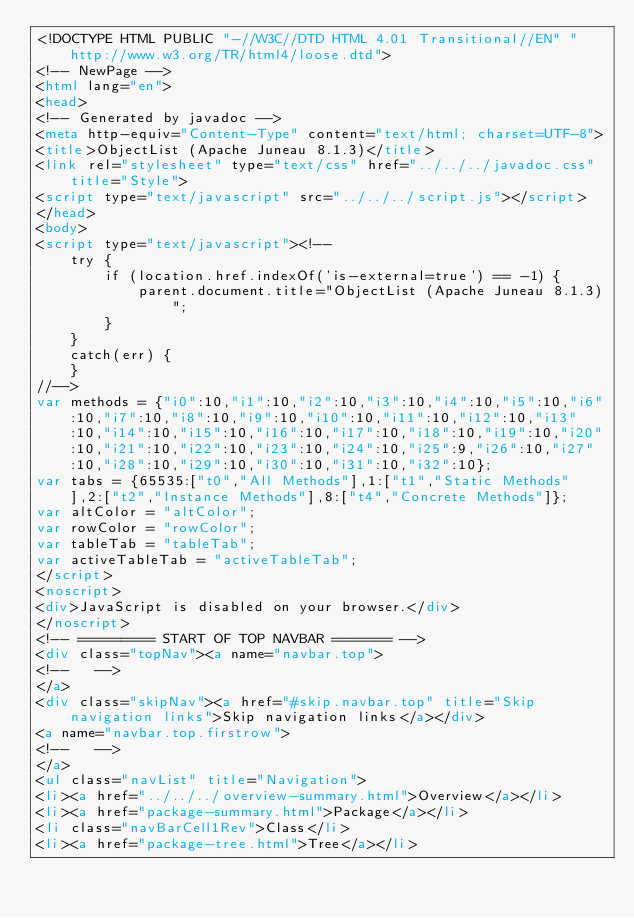Convert code to text. <code><loc_0><loc_0><loc_500><loc_500><_HTML_><!DOCTYPE HTML PUBLIC "-//W3C//DTD HTML 4.01 Transitional//EN" "http://www.w3.org/TR/html4/loose.dtd">
<!-- NewPage -->
<html lang="en">
<head>
<!-- Generated by javadoc -->
<meta http-equiv="Content-Type" content="text/html; charset=UTF-8">
<title>ObjectList (Apache Juneau 8.1.3)</title>
<link rel="stylesheet" type="text/css" href="../../../javadoc.css" title="Style">
<script type="text/javascript" src="../../../script.js"></script>
</head>
<body>
<script type="text/javascript"><!--
    try {
        if (location.href.indexOf('is-external=true') == -1) {
            parent.document.title="ObjectList (Apache Juneau 8.1.3)";
        }
    }
    catch(err) {
    }
//-->
var methods = {"i0":10,"i1":10,"i2":10,"i3":10,"i4":10,"i5":10,"i6":10,"i7":10,"i8":10,"i9":10,"i10":10,"i11":10,"i12":10,"i13":10,"i14":10,"i15":10,"i16":10,"i17":10,"i18":10,"i19":10,"i20":10,"i21":10,"i22":10,"i23":10,"i24":10,"i25":9,"i26":10,"i27":10,"i28":10,"i29":10,"i30":10,"i31":10,"i32":10};
var tabs = {65535:["t0","All Methods"],1:["t1","Static Methods"],2:["t2","Instance Methods"],8:["t4","Concrete Methods"]};
var altColor = "altColor";
var rowColor = "rowColor";
var tableTab = "tableTab";
var activeTableTab = "activeTableTab";
</script>
<noscript>
<div>JavaScript is disabled on your browser.</div>
</noscript>
<!-- ========= START OF TOP NAVBAR ======= -->
<div class="topNav"><a name="navbar.top">
<!--   -->
</a>
<div class="skipNav"><a href="#skip.navbar.top" title="Skip navigation links">Skip navigation links</a></div>
<a name="navbar.top.firstrow">
<!--   -->
</a>
<ul class="navList" title="Navigation">
<li><a href="../../../overview-summary.html">Overview</a></li>
<li><a href="package-summary.html">Package</a></li>
<li class="navBarCell1Rev">Class</li>
<li><a href="package-tree.html">Tree</a></li></code> 